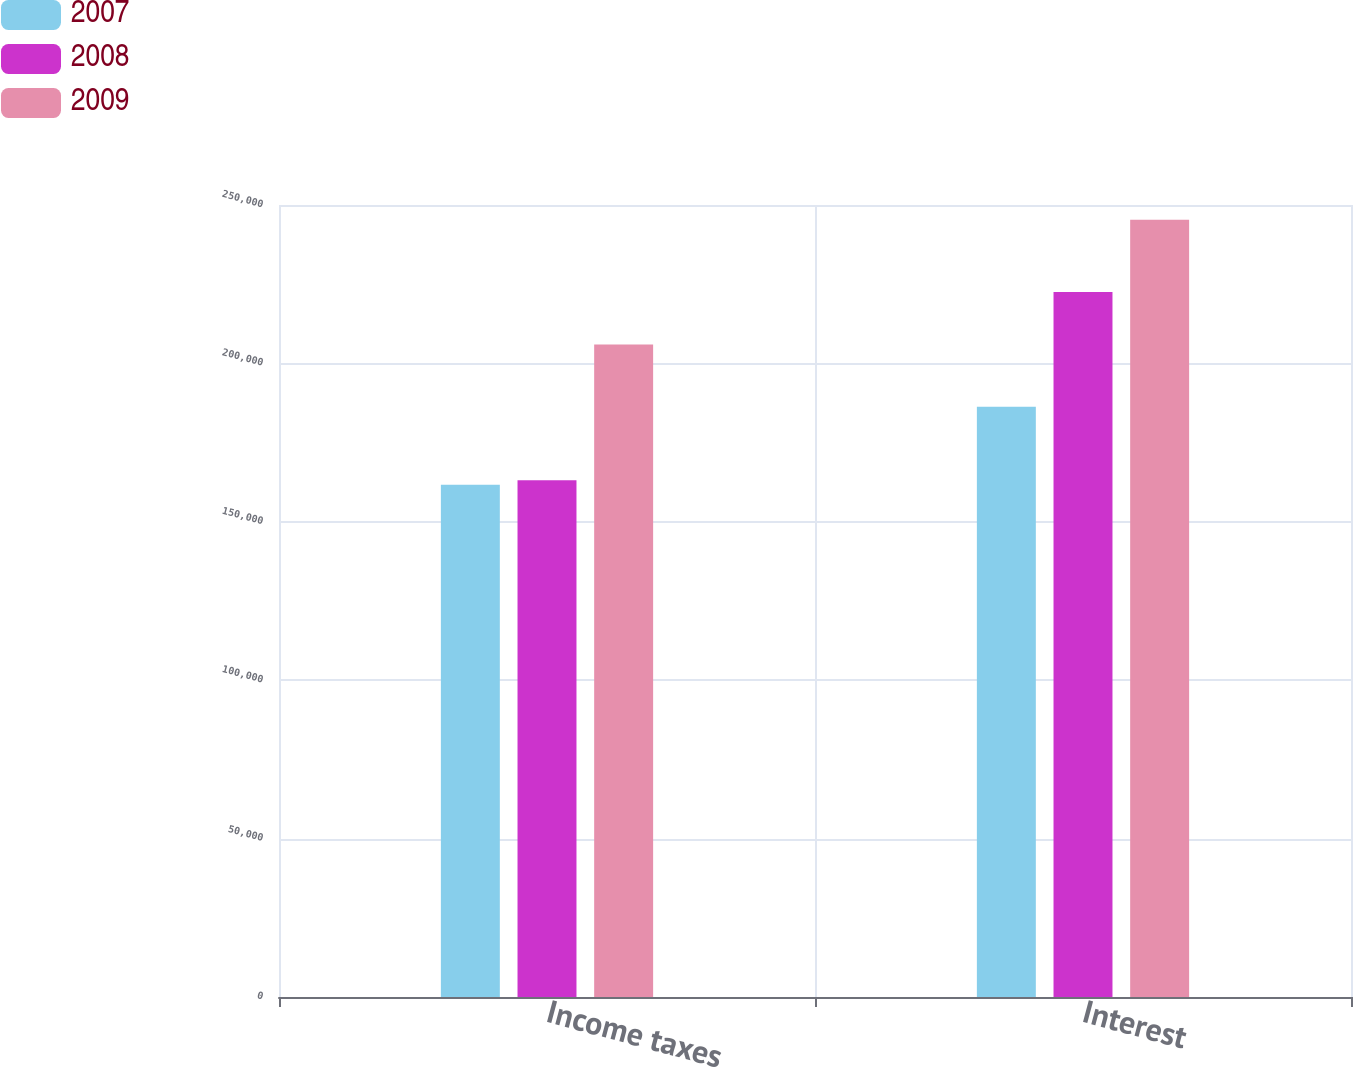Convert chart to OTSL. <chart><loc_0><loc_0><loc_500><loc_500><stacked_bar_chart><ecel><fcel>Income taxes<fcel>Interest<nl><fcel>2007<fcel>161671<fcel>186280<nl><fcel>2008<fcel>163147<fcel>222558<nl><fcel>2009<fcel>205955<fcel>245325<nl></chart> 